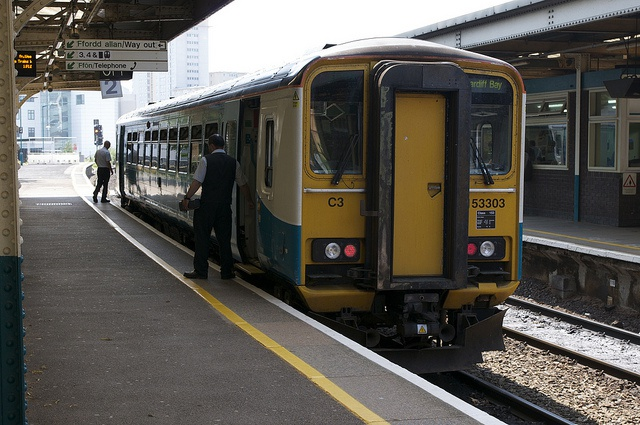Describe the objects in this image and their specific colors. I can see train in gray, black, and olive tones, people in gray, black, and purple tones, people in gray, black, darkgray, and lightgray tones, and traffic light in gray, darkgray, lavender, and darkblue tones in this image. 